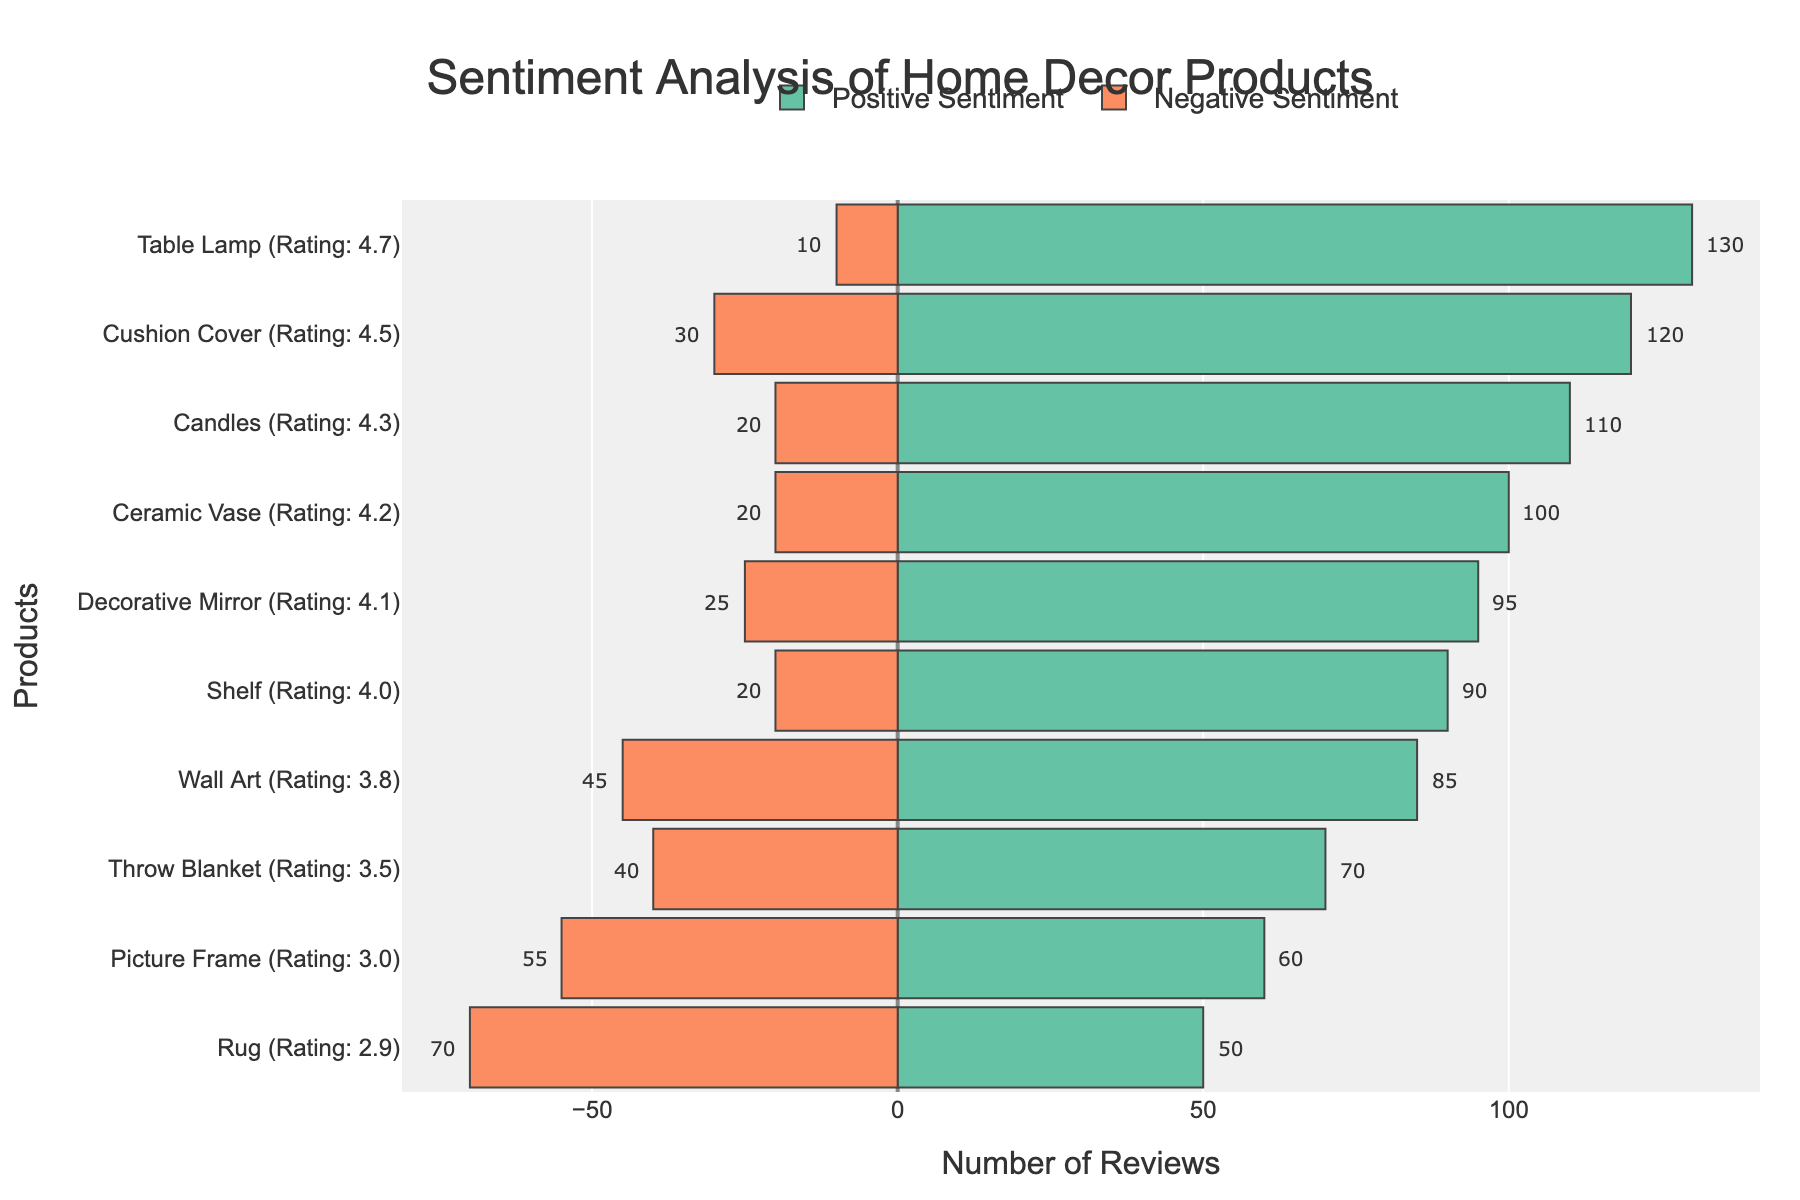What's the total number of reviews for the Cushion Cover? The Cushion Cover has 120 positive reviews and 30 negative reviews. Summing them gives 120 + 30 = 150 reviews.
Answer: 150 Which product has the highest number of positive reviews? By examining the chart, the Table Lamp has the highest number of positive reviews at 130.
Answer: Table Lamp How many more positive reviews does Wall Art have compared to Throw Blanket? Wall Art has 85 positive reviews, and Throw Blanket has 70 positive reviews. The difference is 85 - 70 = 15 more positive reviews.
Answer: 15 Which product has the highest negative sentiment? By examining the chart, the Rug has the highest number of negative reviews at 70.
Answer: Rug Does the Candles product have a higher rating than the Decorative Mirror? By looking at the y-axis labels, Candles has a rating of 4.3, and Decorative Mirror has a rating of 4.1. 4.3 is higher than 4.1.
Answer: Yes What is the difference between positive and negative reviews for the Picture Frame? The Picture Frame has 60 positive reviews and 55 negative reviews. The difference is 60 - 55 = 5 reviews.
Answer: 5 Which product has more negative reviews: Shelf or Ceramic Vase? Shelf has 20 negative reviews, and Ceramic Vase has 20 negative reviews, so they have the same number of negative reviews.
Answer: Same How many products have a rating of 4.0 or higher? Counting the products with ratings of 4.0 or higher: Cushion Cover, Ceramic Vase, Table Lamp, Decorative Mirror, Candles, and Shelf. There are 6 products.
Answer: 6 By how many reviews do positive sentiments exceed negative sentiments for the Table Lamp? The Table Lamp has 130 positive reviews and 10 negative reviews. The difference is 130 - 10 = 120 reviews.
Answer: 120 What is the combined total for positive reviews of products with a rating above 4.0? Products with ratings above 4.0: Cushion Cover (120), Ceramic Vase (100), Table Lamp (130), Candles (110). Total positive reviews = 120 + 100 + 130 + 110 = 460.
Answer: 460 